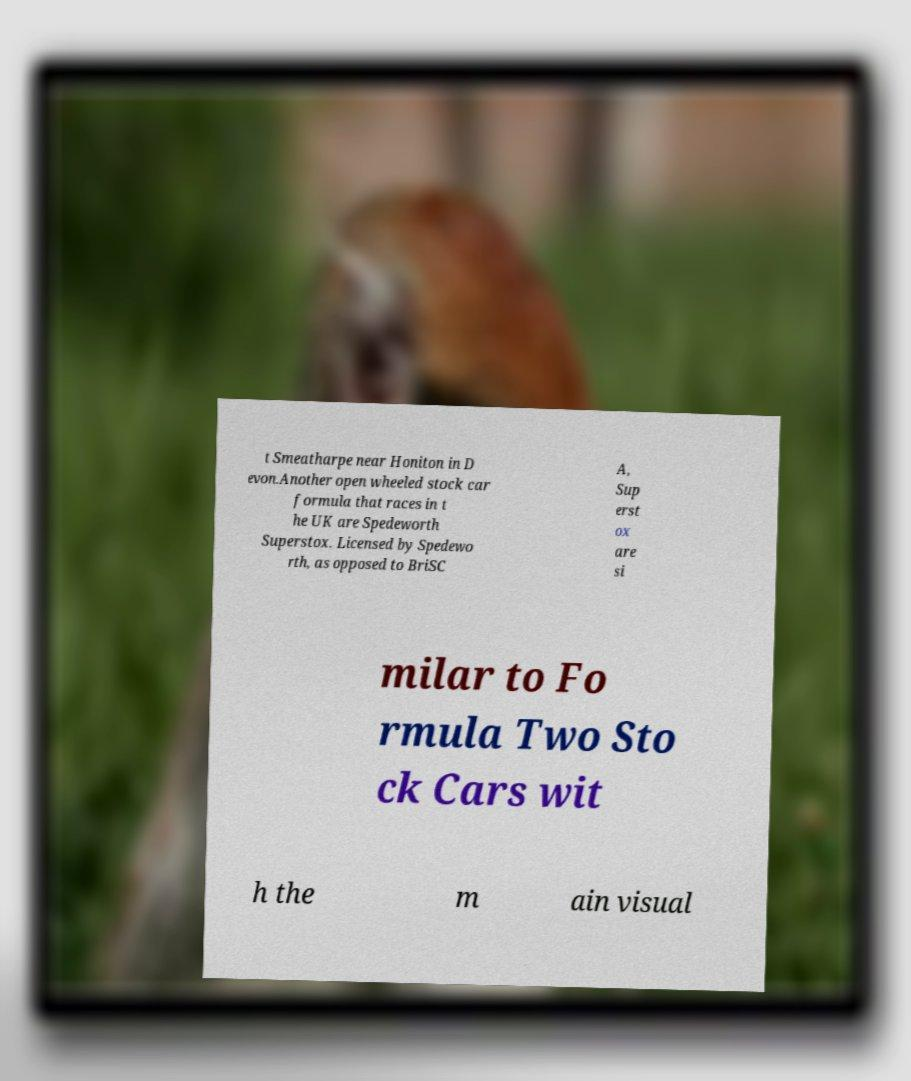What messages or text are displayed in this image? I need them in a readable, typed format. t Smeatharpe near Honiton in D evon.Another open wheeled stock car formula that races in t he UK are Spedeworth Superstox. Licensed by Spedewo rth, as opposed to BriSC A, Sup erst ox are si milar to Fo rmula Two Sto ck Cars wit h the m ain visual 